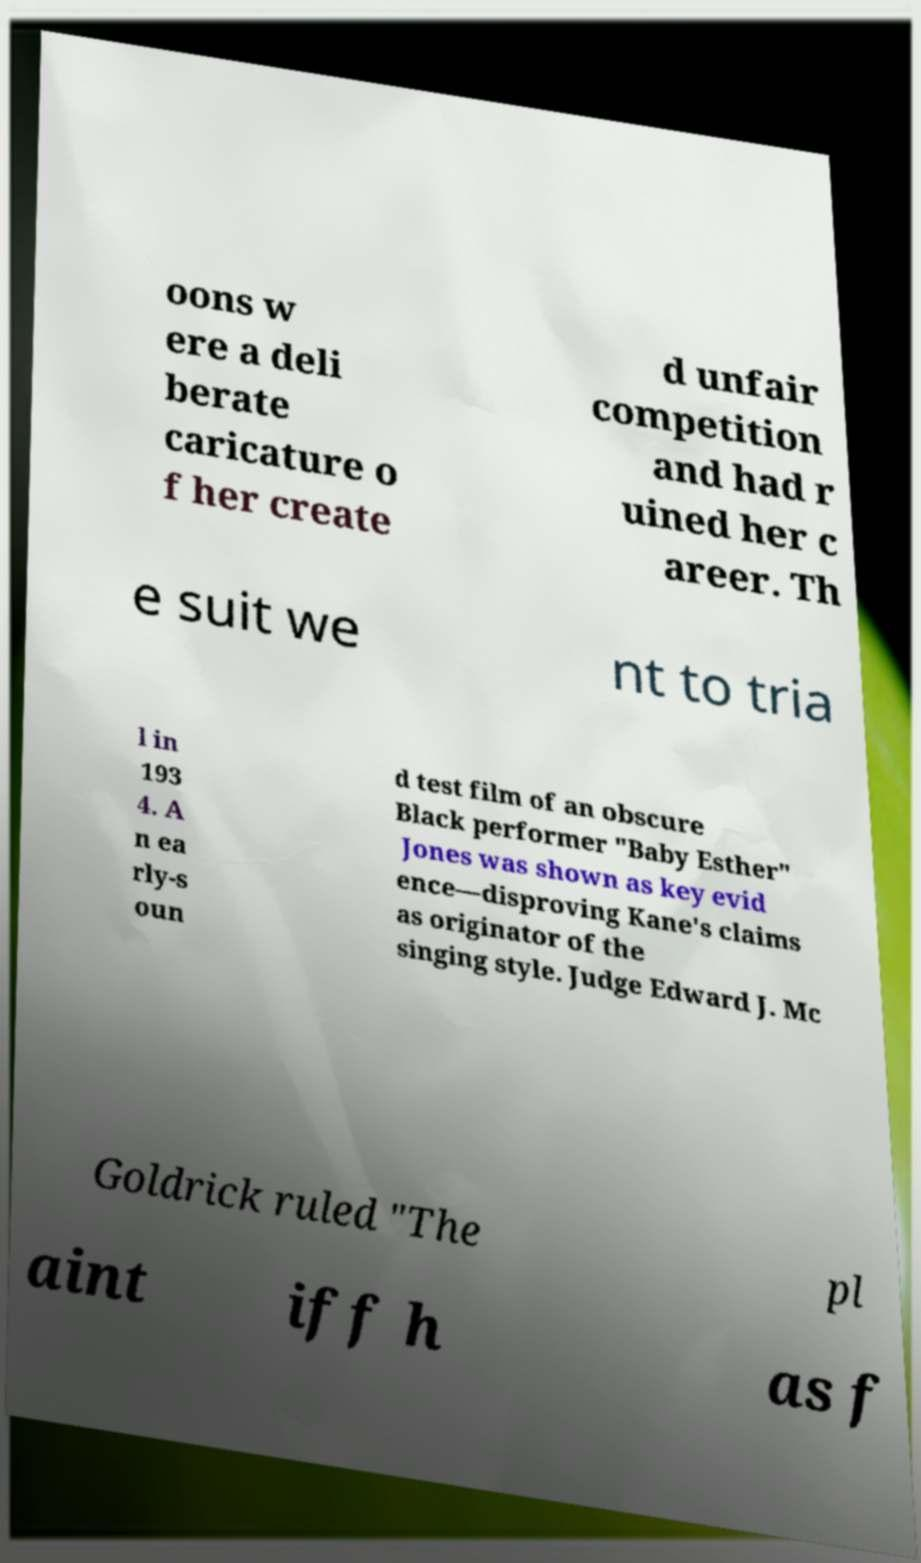Could you assist in decoding the text presented in this image and type it out clearly? oons w ere a deli berate caricature o f her create d unfair competition and had r uined her c areer. Th e suit we nt to tria l in 193 4. A n ea rly-s oun d test film of an obscure Black performer "Baby Esther" Jones was shown as key evid ence—disproving Kane's claims as originator of the singing style. Judge Edward J. Mc Goldrick ruled "The pl aint iff h as f 